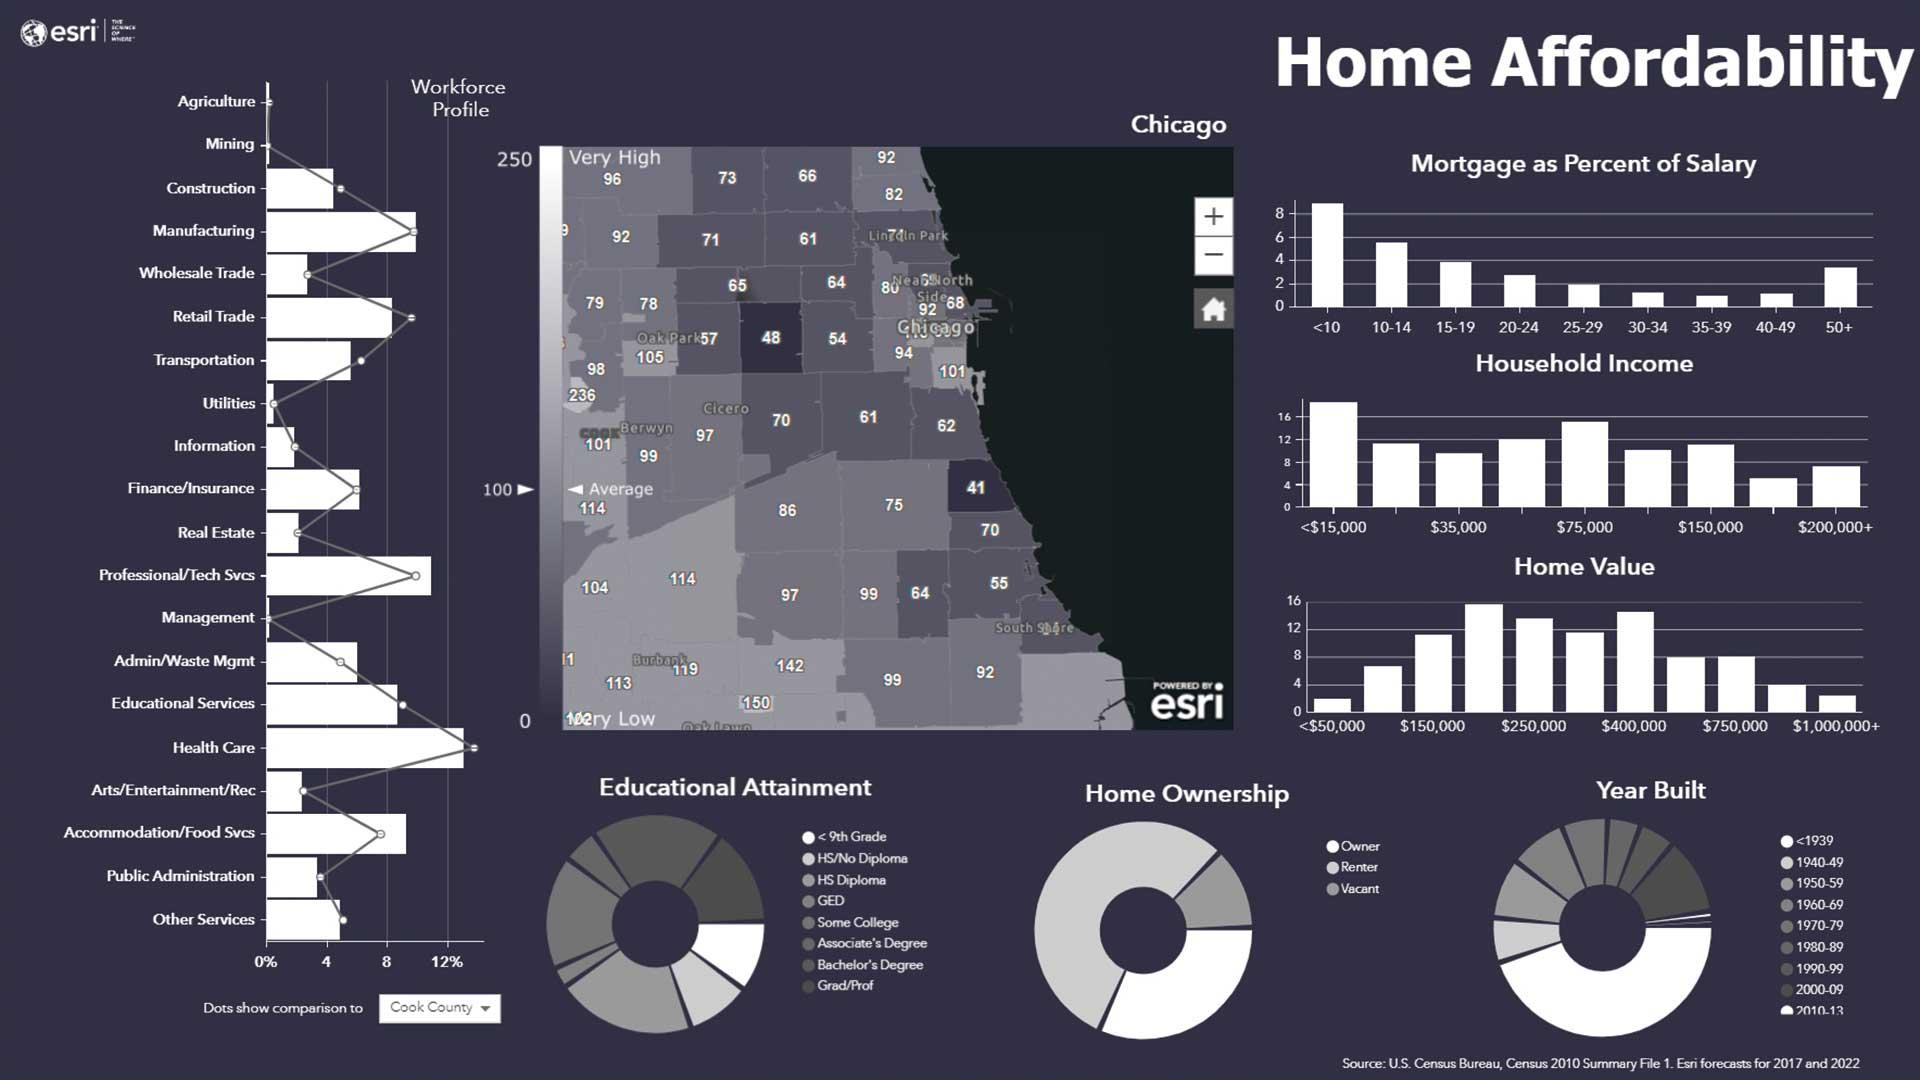Outline some significant characteristics in this image. How many workforce profiles are listed? Between 2010 and 2013, the maximum number of houses were built. The home ownership is divided into three categories. The maximum number of home ownership lies in the category of Renter. 